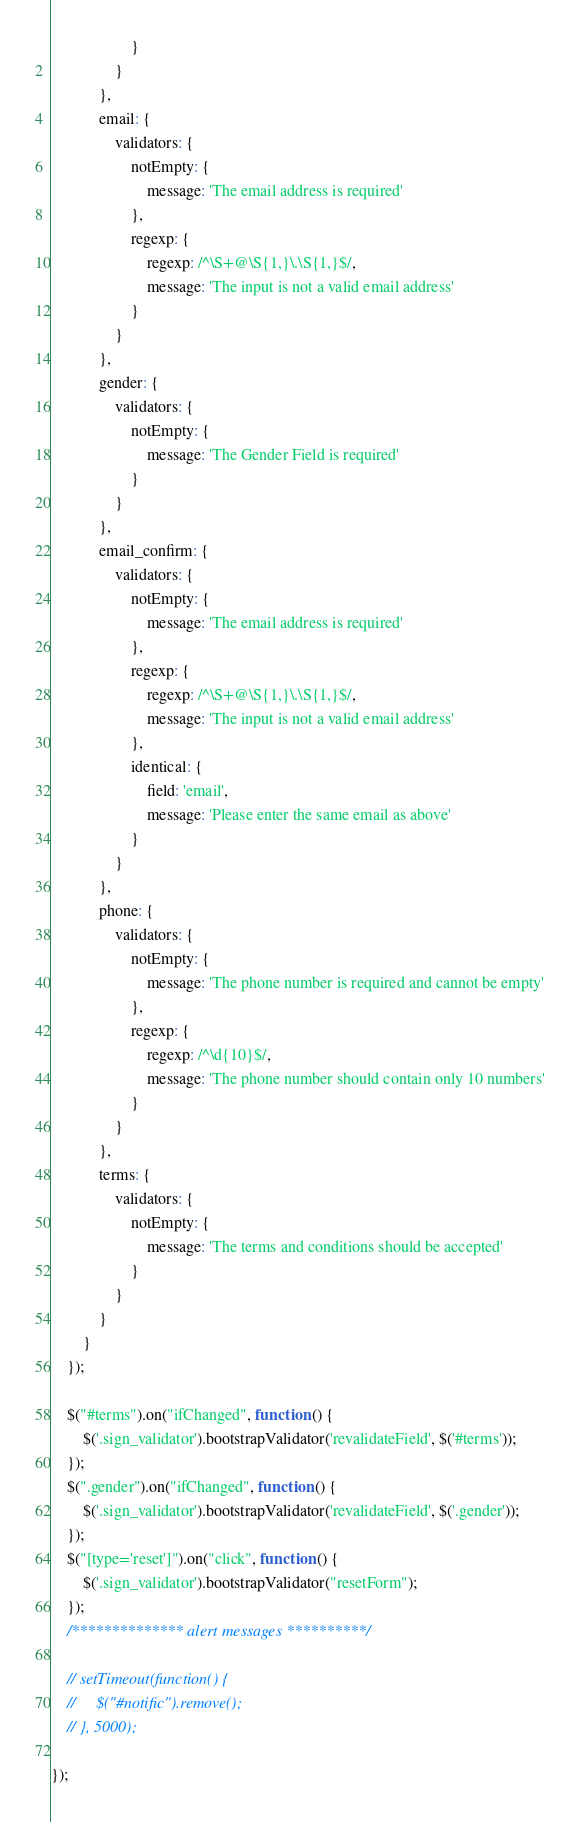<code> <loc_0><loc_0><loc_500><loc_500><_JavaScript_>                    }
                }
            },
            email: {
                validators: {
                    notEmpty: {
                        message: 'The email address is required'
                    },
                    regexp: {
                        regexp: /^\S+@\S{1,}\.\S{1,}$/,
                        message: 'The input is not a valid email address'
                    }
                }
            },
            gender: {
                validators: {
                    notEmpty: {
                        message: 'The Gender Field is required'
                    }
                }
            },
            email_confirm: {
                validators: {
                    notEmpty: {
                        message: 'The email address is required'
                    },
                    regexp: {
                        regexp: /^\S+@\S{1,}\.\S{1,}$/,
                        message: 'The input is not a valid email address'
                    },
                    identical: {
                        field: 'email',
                        message: 'Please enter the same email as above'
                    }
                }
            },
            phone: {
                validators: {
                    notEmpty: {
                        message: 'The phone number is required and cannot be empty'
                    },
                    regexp: {
                        regexp: /^\d{10}$/,
                        message: 'The phone number should contain only 10 numbers'
                    }
                }
            },
            terms: {
                validators: {
                    notEmpty: {
                        message: 'The terms and conditions should be accepted'
                    }
                }
            }
        }
    });

    $("#terms").on("ifChanged", function () {
        $('.sign_validator').bootstrapValidator('revalidateField', $('#terms'));
    });
    $(".gender").on("ifChanged", function () {
        $('.sign_validator').bootstrapValidator('revalidateField', $('.gender'));
    });
    $("[type='reset']").on("click", function () {
        $('.sign_validator').bootstrapValidator("resetForm");
    });
    /************** alert messages **********/

    // setTimeout(function() {
    //     $("#notific").remove();
    // }, 5000);

});</code> 